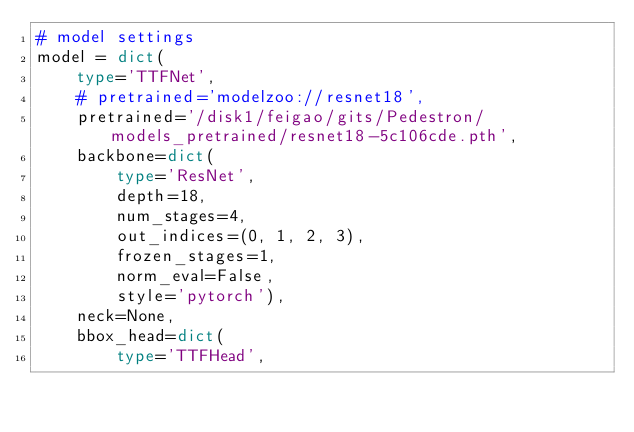Convert code to text. <code><loc_0><loc_0><loc_500><loc_500><_Python_># model settings
model = dict(
    type='TTFNet',
    # pretrained='modelzoo://resnet18',
    pretrained='/disk1/feigao/gits/Pedestron/models_pretrained/resnet18-5c106cde.pth',
    backbone=dict(
        type='ResNet',
        depth=18,
        num_stages=4,
        out_indices=(0, 1, 2, 3),
        frozen_stages=1,
        norm_eval=False,
        style='pytorch'),
    neck=None,
    bbox_head=dict(
        type='TTFHead',</code> 